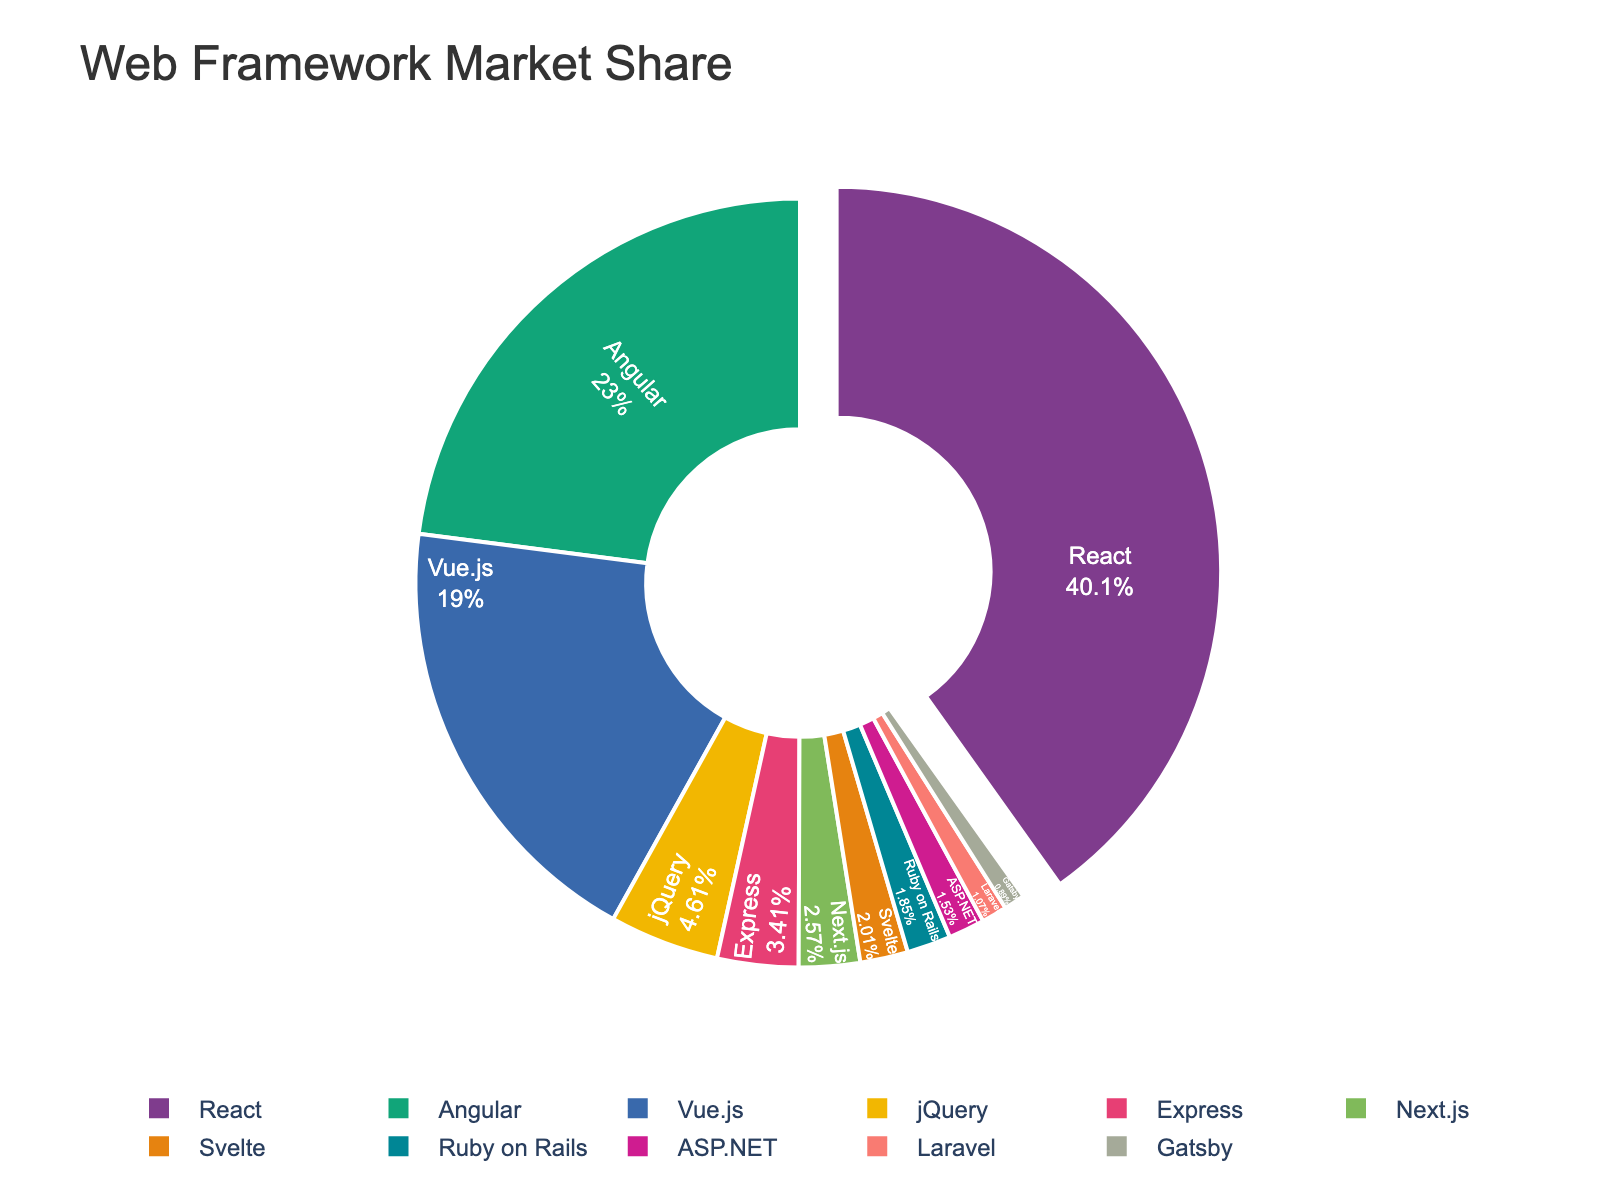what's the largest market share held by a framework? The largest slice of the pie chart represents the framework with the highest market share. By observing the chart, we can see that React has the largest share.
Answer: React what's the combined market share of React and Angular? To find the combined market share, sum the shares of React and Angular. React has 40.14% and Angular has 22.96%. So, the combined share is 40.14 + 22.96 = 63.10%.
Answer: 63.10% which framework has a higher market share, Vue.js or Angular? By comparing the sizes of the slices, Angular has a larger market share at 22.96% compared to Vue.js at 18.97%.
Answer: Angular how much larger is React's market share compared to jQuery's market share? Subtract jQuery's market share from React's. React has 40.14% and jQuery has 4.61%. So, the difference is 40.14 - 4.61 = 35.53%.
Answer: 35.53% identify the least popular framework in the figure The smallest slice of the pie chart represents the least popular framework. Gatsby is the smallest slice with a 0.89% market share.
Answer: Gatsby what's the difference in market share between Express and Next.js? Subtract Next.js' market share from Express'. Express has 3.41% and Next.js has 2.57%. Thus, the difference is 3.41 - 2.57 = 0.84%.
Answer: 0.84% what fraction of the market do Ruby on Rails and ASP.NET together hold? To find the combined fraction, add their market shares. Ruby on Rails has 1.85% and ASP.NET has 1.53%. So, the combined share is 1.85 + 1.53 = 3.38%.
Answer: 3.38% rank the top three frameworks in order of their market share Based on the largest slices, the top three frameworks are React (40.14%), Angular (22.96%), and Vue.js (18.97%).
Answer: React, Angular, Vue.js estimate the combined market share of frameworks with less than 2% share Identify frameworks with less than 2%: Svelte (2.01%), Ruby on Rails (1.85%), ASP.NET (1.53%), Laravel (1.07%), and Gatsby (0.89%). Their combined share is
2.01 + 1.85 + 1.53 + 1.07 + 0.89 = 7.35%.
Answer: 7.35% what's the visual impact of React's market share on the chart? The largest slice, React, is also pulled out slightly from the rest, highlighting its leading position in the market share visually.
Answer: Dominates 